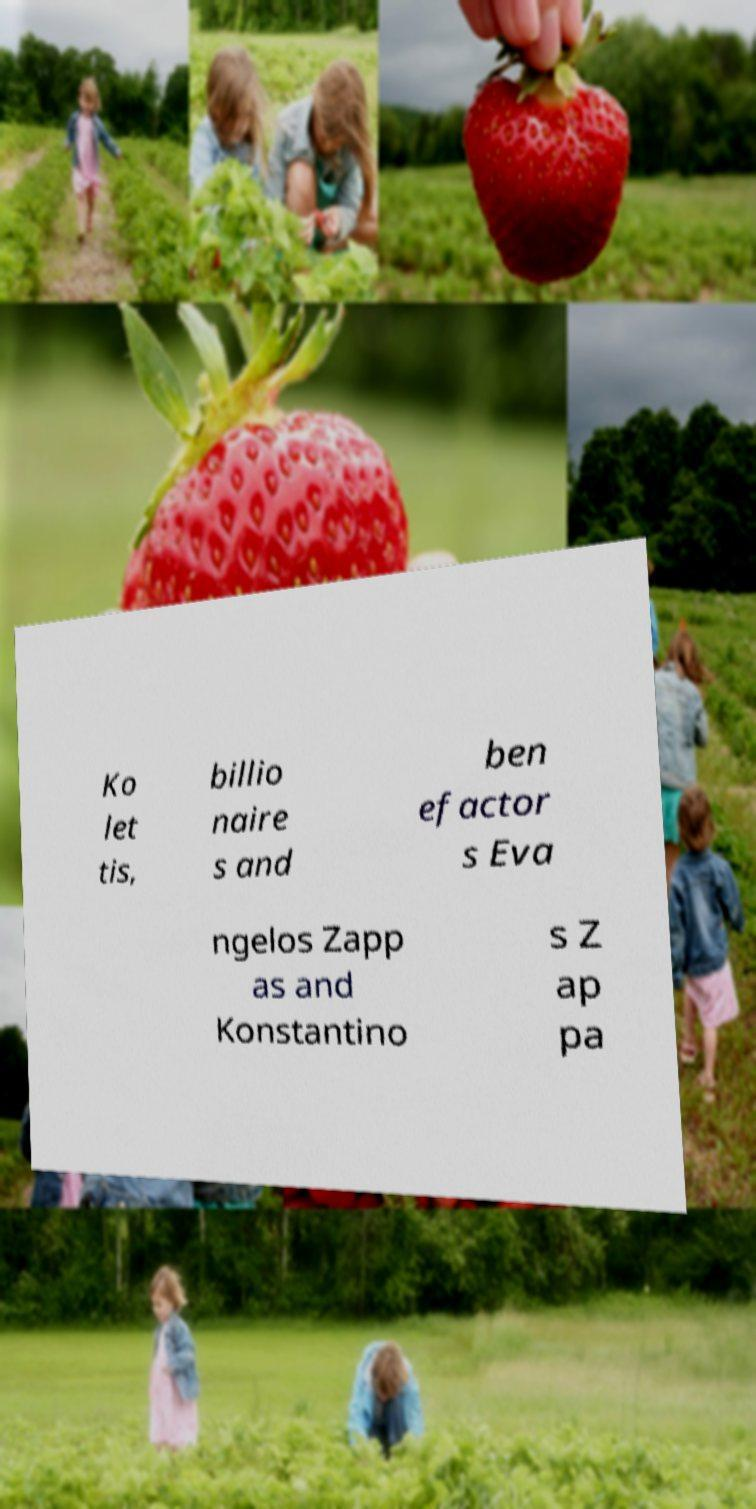Please read and relay the text visible in this image. What does it say? Ko let tis, billio naire s and ben efactor s Eva ngelos Zapp as and Konstantino s Z ap pa 